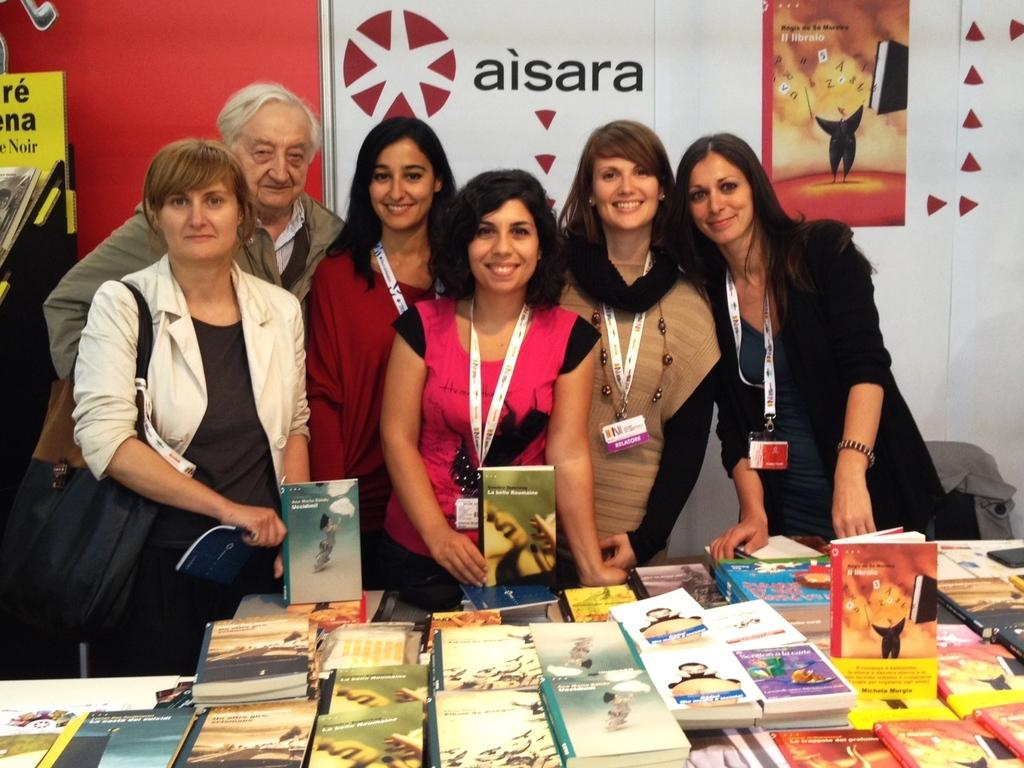<image>
Summarize the visual content of the image. five women standing behind a table of books and in front of an aisara sign 